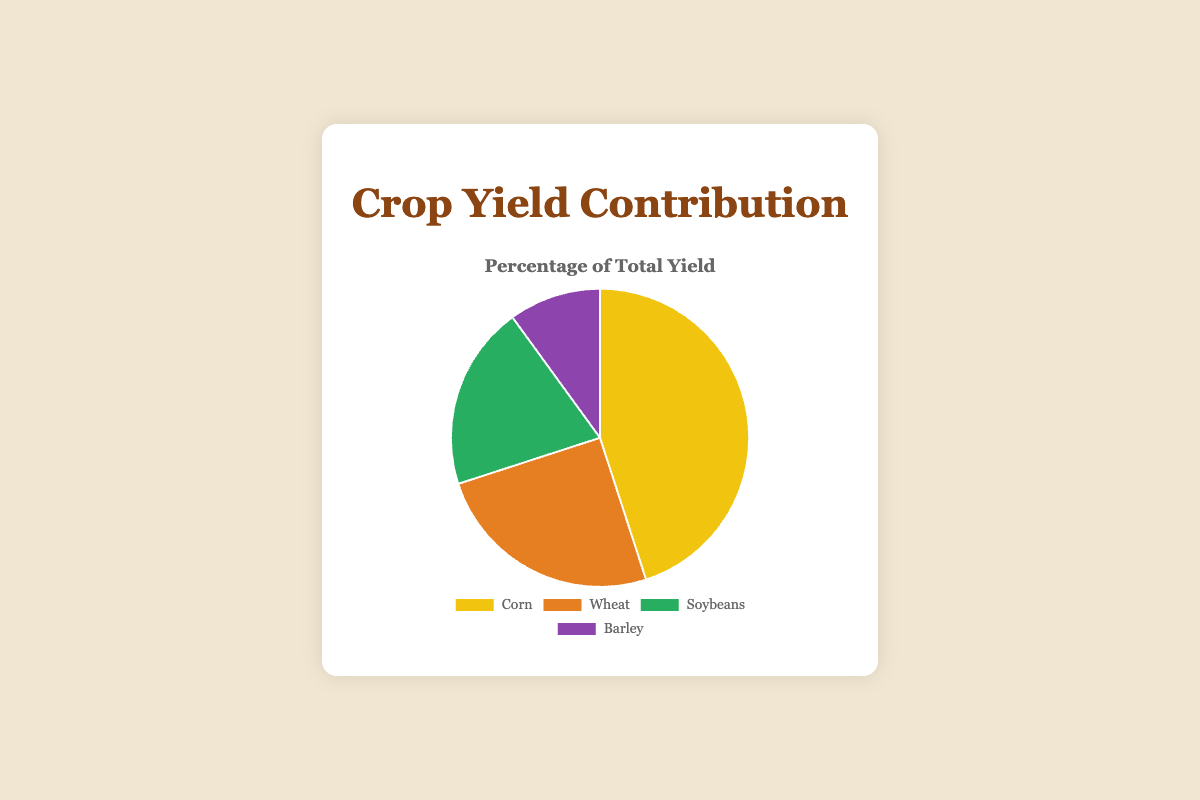What is the contribution percentage of Corn to the total yield? The contribution percentage of Corn is directly shown on the pie chart, where it occupies 45% of the total yield.
Answer: 45% Which crop has the smallest yield contribution? The smallest yield contribution is the crop with the smallest segment in the pie chart, which is Barley at 10%.
Answer: Barley Compare the yield contributions of Soybeans and Wheat. Which one is larger and by how much? Soybeans contribute 20% and Wheat contributes 25% to the total yield. The difference is 25% - 20% = 5%.
Answer: Wheat by 5% What is the total yield contribution of Corn and Soybeans combined? The yield contribution of Corn is 45% and that of Soybeans is 20%. Their combined contribution is 45% + 20% = 65%.
Answer: 65% Among Corn, Wheat, and Barley, which crop has the second highest yield contribution? Corn has the highest yield contribution at 45%, Wheat has the second highest at 25%, and Barley has the lowest at 10%. Thus, Wheat is second highest.
Answer: Wheat If Corn's yield contribution was increased by 10%, what would its new percentage be? Currently, Corn's yield contribution is 45%. An increase of 10% would make it 45% + 10% = 55%.
Answer: 55% What is the difference in yield contribution between the highest and the lowest yield percentage crops? The highest yield percentage is for Corn at 45%, and the lowest is for Barley at 10%. The difference is 45% - 10% = 35%.
Answer: 35% How do the combined yield contributions of Corn and Wheat compare to the combined contributions of Soybeans and Barley? Combined contributions of Corn and Wheat are 45% + 25% = 70%. Combined contributions of Soybeans and Barley are 20% + 10% = 30%. Thus, Corn and Wheat's combined contributions are higher.
Answer: Corn and Wheat by 40% Which crop types are represented with green and purple colors respectively, and what are their yield percentages? The green color represents Soybeans, which have a yield contribution of 20%, and the purple color represents Barley, which has a yield contribution of 10%.
Answer: Soybeans (20%), Barley (10%) What is the average yield contribution of all the crops? Adding the yield contributions: 45% (Corn) + 25% (Wheat) + 20% (Soybeans) + 10% (Barley) = 100%. Dividing by the number of crops (4), the average contribution is 100% / 4 = 25%.
Answer: 25% 